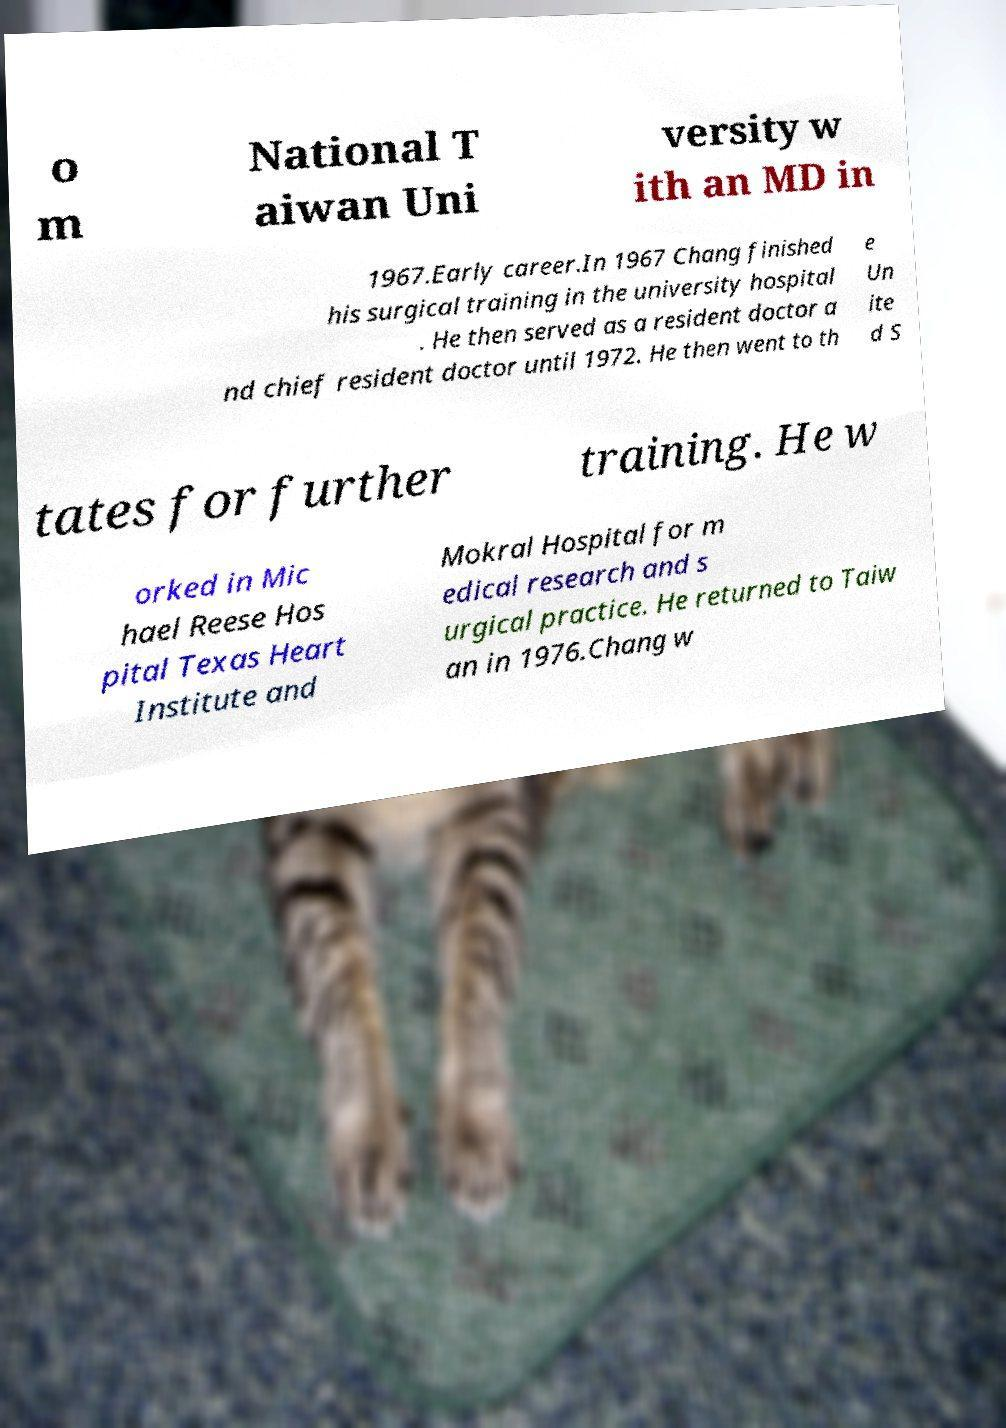I need the written content from this picture converted into text. Can you do that? o m National T aiwan Uni versity w ith an MD in 1967.Early career.In 1967 Chang finished his surgical training in the university hospital . He then served as a resident doctor a nd chief resident doctor until 1972. He then went to th e Un ite d S tates for further training. He w orked in Mic hael Reese Hos pital Texas Heart Institute and Mokral Hospital for m edical research and s urgical practice. He returned to Taiw an in 1976.Chang w 